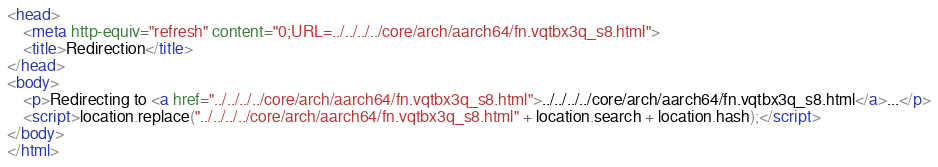Convert code to text. <code><loc_0><loc_0><loc_500><loc_500><_HTML_><head>
    <meta http-equiv="refresh" content="0;URL=../../../../core/arch/aarch64/fn.vqtbx3q_s8.html">
    <title>Redirection</title>
</head>
<body>
    <p>Redirecting to <a href="../../../../core/arch/aarch64/fn.vqtbx3q_s8.html">../../../../core/arch/aarch64/fn.vqtbx3q_s8.html</a>...</p>
    <script>location.replace("../../../../core/arch/aarch64/fn.vqtbx3q_s8.html" + location.search + location.hash);</script>
</body>
</html></code> 